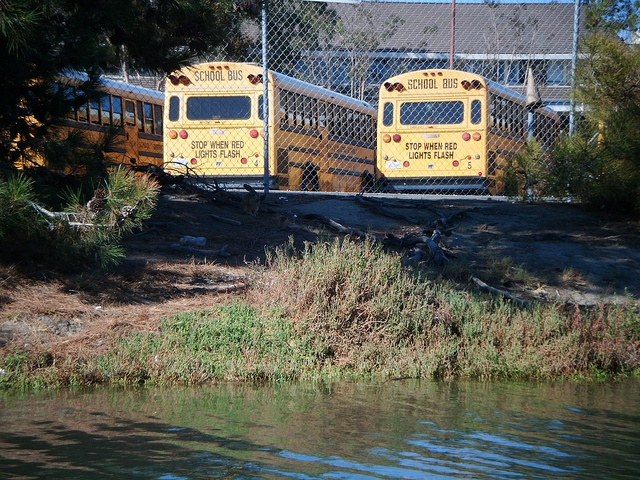Describe the objects in this image and their specific colors. I can see bus in gray, khaki, and black tones, bus in gray, khaki, black, and darkgray tones, and bus in gray, black, maroon, and brown tones in this image. 